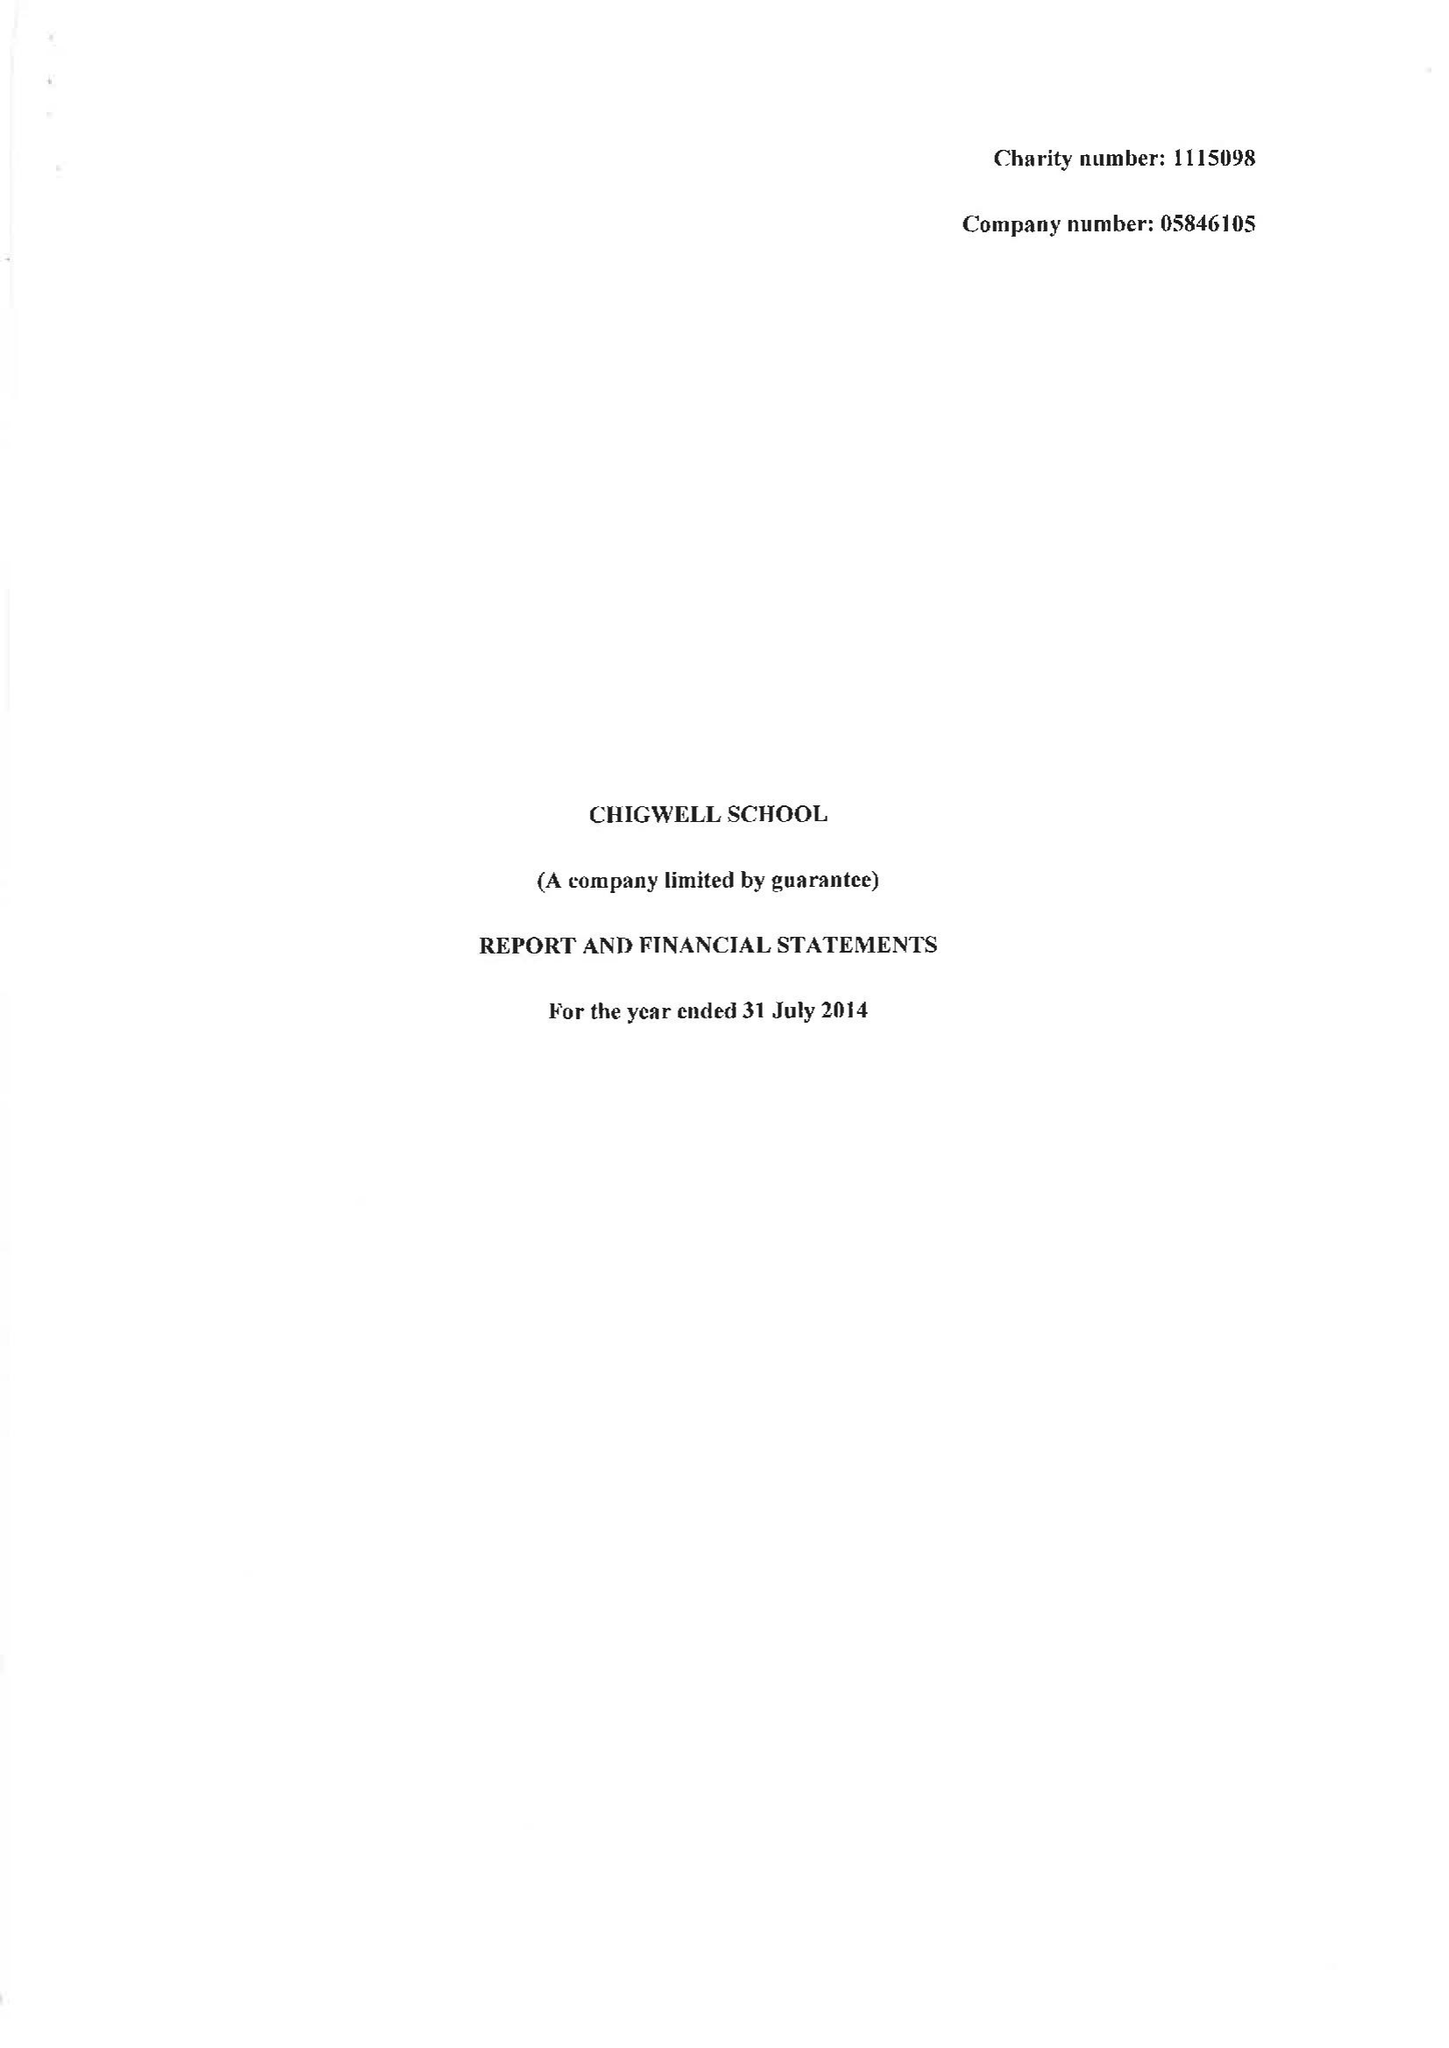What is the value for the report_date?
Answer the question using a single word or phrase. 2014-07-31 